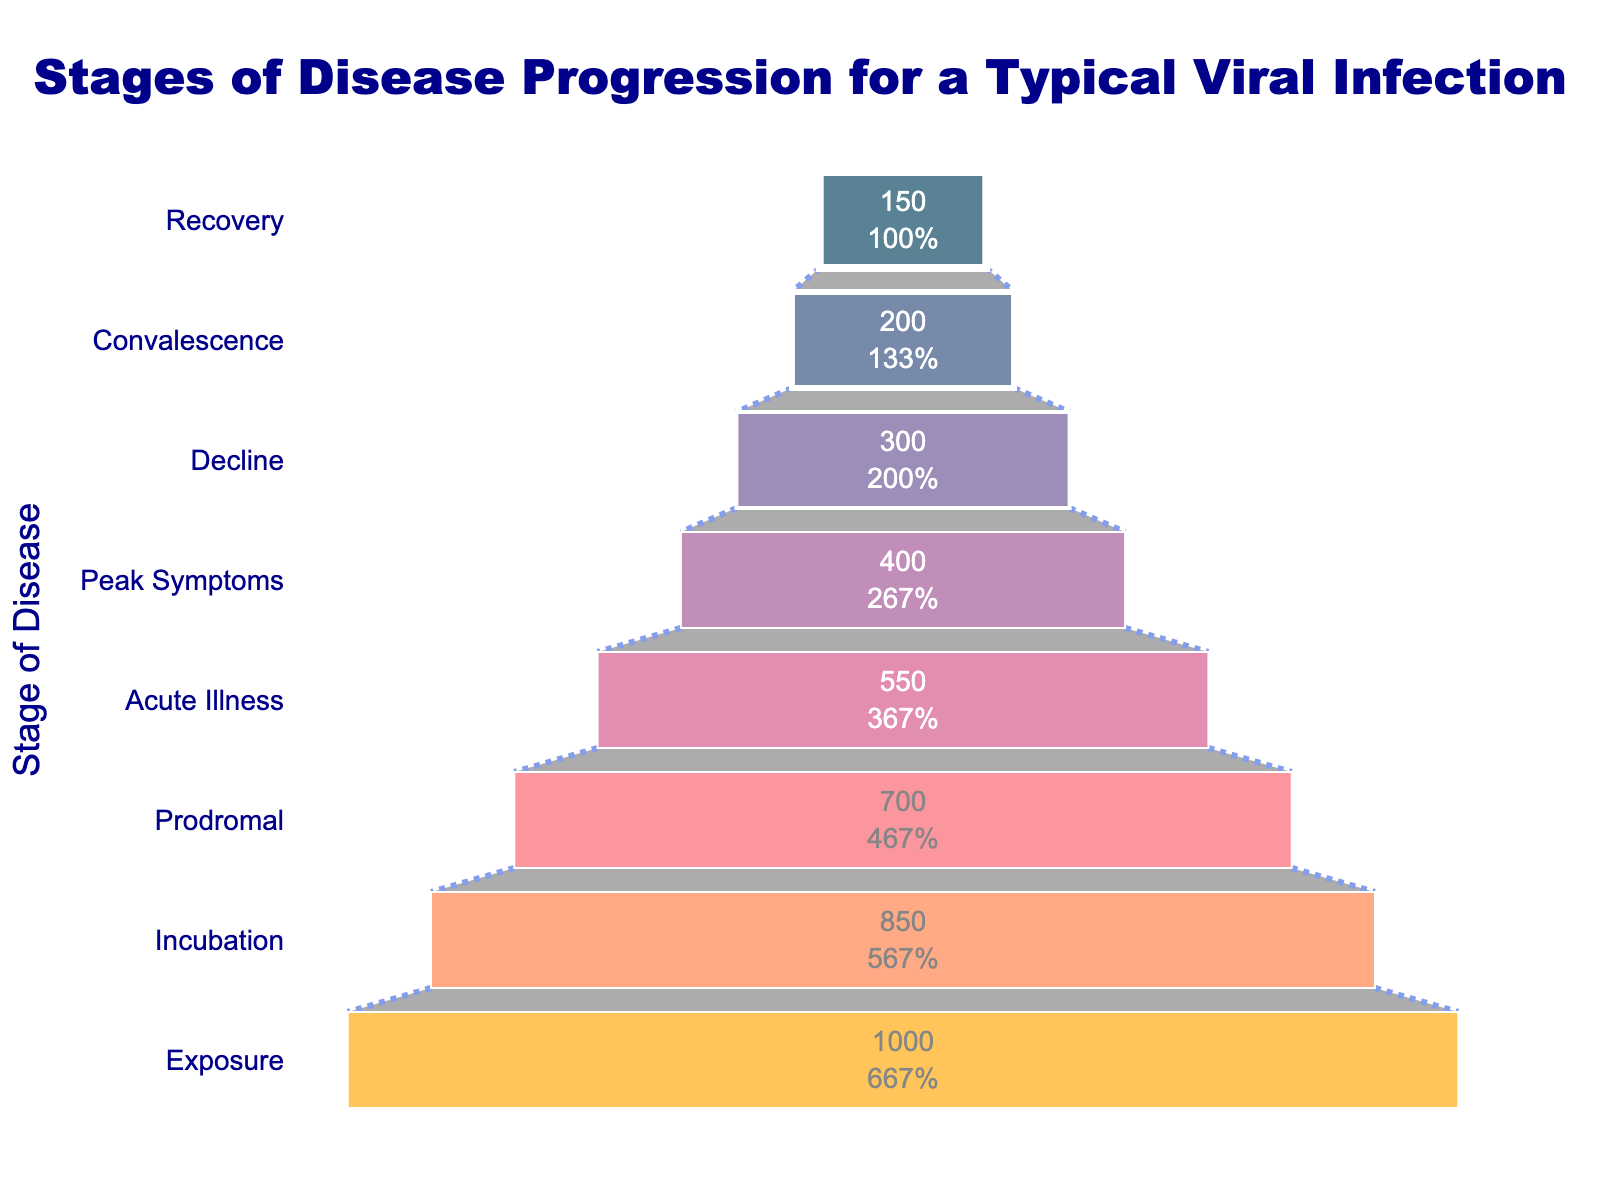What is the title of the figure? The title is prominently displayed at the top of the chart. It reads "Stages of Disease Progression for a Typical Viral Infection".
Answer: Stages of Disease Progression for a Typical Viral Infection How many stages of disease progression are shown in the figure? The y-axis lists all the stages of disease progression, which include Exposure, Incubation, Prodromal, Acute Illness, Peak Symptoms, Decline, Convalescence, and Recovery. There are 8 stages in total.
Answer: 8 What is the number of cases at the Exposure stage? The funnel chart shows the number of cases for each stage inside the funnel areas. The number of cases for the Exposure stage is 1000 as indicated in the chart.
Answer: 1000 Which stage has the fewest number of cases? By visually inspecting the funnel chart, the smallest area corresponds to the Recovery stage, which has the lowest number of cases. The number of cases at this stage is indicated as 150.
Answer: Recovery What percentage of initial cases are in the Convalescence stage? The chart provides this information in the text inside each section of the funnel. For the Convalescence stage, it states the number of cases (200) and its percentage of the initial stage (1000 cases). Calculating 200 divided by 1000 gives 20%.
Answer: 20% How many cases progress from Acute Illness to Recovery? First, identify the number of cases at the "Acute Illness" stage (550) and at the "Recovery" stage (150). The difference between these stages represents the cases that have progressed from Acute Illness to Recovery, which is 550 - 150 = 400.
Answer: 400 What is the drop in the number of cases from the Incubation stage to the Peak Symptoms stage? Look at the number of cases for both stages: Incubation has 850 cases, and Peak Symptoms has 400 cases. The drop is calculated by subtracting the smaller from the larger number: 850 - 400 = 450.
Answer: 450 How many more cases are there in the Peak Symptoms stage than in the Decline stage? The funnel chart shows 400 cases in the Peak Symptoms stage and 300 cases in the Decline stage. The difference is 400 - 300 = 100 cases.
Answer: 100 What color represents the Decline stage in the chart? The visualization uses different colors for each stage. The Decline stage, according to the final segment just above the Convalescence stage and before Peak Symptoms, is colored with a shade of orange.
Answer: Orange What is the total number of cases represented by the funnel chart? Add the number of cases for each stage: 1000 (Exposure) + 850 (Incubation) + 700 (Prodromal) + 550 (Acute Illness) + 400 (Peak Symptoms) + 300 (Decline) + 200 (Convalescence) + 150 (Recovery). The total sum is 4150.
Answer: 4150 